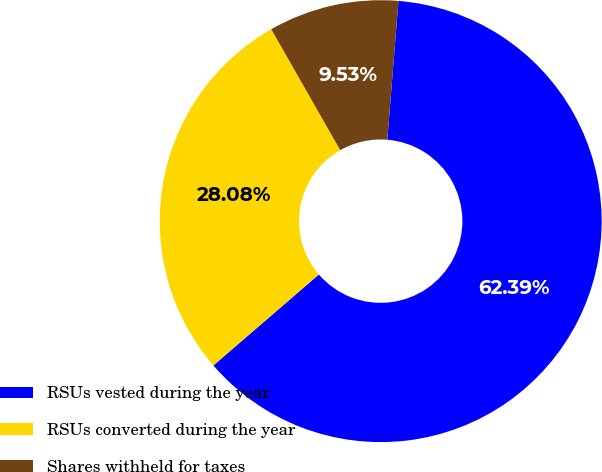Convert chart to OTSL. <chart><loc_0><loc_0><loc_500><loc_500><pie_chart><fcel>RSUs vested during the year<fcel>RSUs converted during the year<fcel>Shares withheld for taxes<nl><fcel>62.39%<fcel>28.08%<fcel>9.53%<nl></chart> 